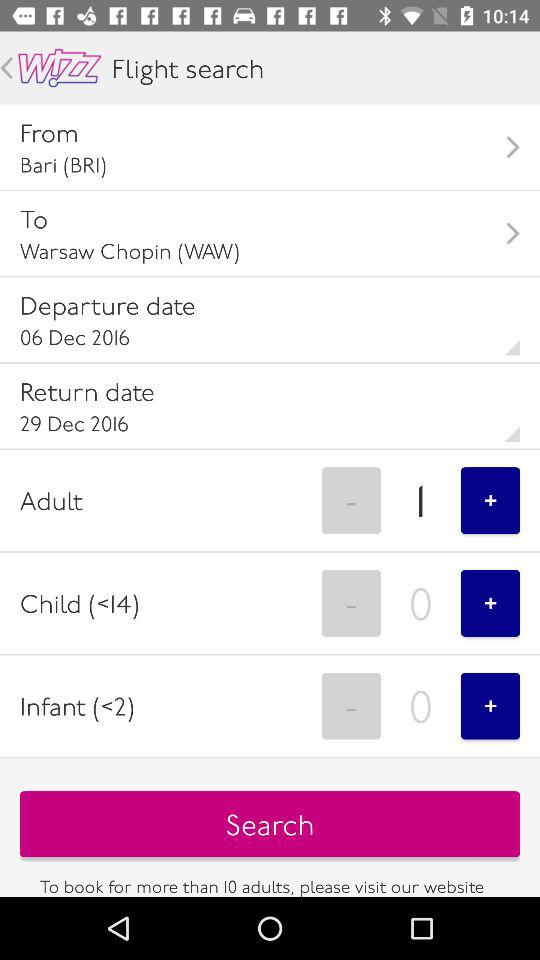The flight is searched for how many people? The flight is searched for 1 person. 